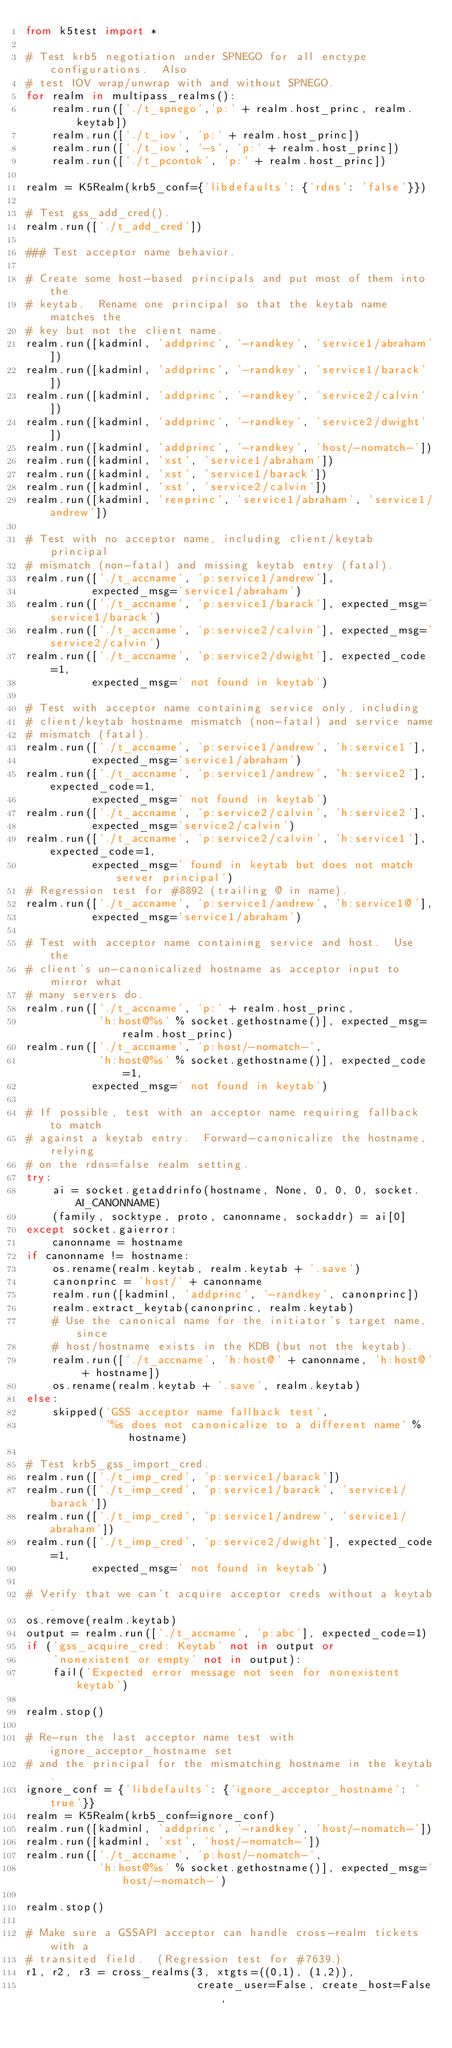Convert code to text. <code><loc_0><loc_0><loc_500><loc_500><_Python_>from k5test import *

# Test krb5 negotiation under SPNEGO for all enctype configurations.  Also
# test IOV wrap/unwrap with and without SPNEGO.
for realm in multipass_realms():
    realm.run(['./t_spnego','p:' + realm.host_princ, realm.keytab])
    realm.run(['./t_iov', 'p:' + realm.host_princ])
    realm.run(['./t_iov', '-s', 'p:' + realm.host_princ])
    realm.run(['./t_pcontok', 'p:' + realm.host_princ])

realm = K5Realm(krb5_conf={'libdefaults': {'rdns': 'false'}})

# Test gss_add_cred().
realm.run(['./t_add_cred'])

### Test acceptor name behavior.

# Create some host-based principals and put most of them into the
# keytab.  Rename one principal so that the keytab name matches the
# key but not the client name.
realm.run([kadminl, 'addprinc', '-randkey', 'service1/abraham'])
realm.run([kadminl, 'addprinc', '-randkey', 'service1/barack'])
realm.run([kadminl, 'addprinc', '-randkey', 'service2/calvin'])
realm.run([kadminl, 'addprinc', '-randkey', 'service2/dwight'])
realm.run([kadminl, 'addprinc', '-randkey', 'host/-nomatch-'])
realm.run([kadminl, 'xst', 'service1/abraham'])
realm.run([kadminl, 'xst', 'service1/barack'])
realm.run([kadminl, 'xst', 'service2/calvin'])
realm.run([kadminl, 'renprinc', 'service1/abraham', 'service1/andrew'])

# Test with no acceptor name, including client/keytab principal
# mismatch (non-fatal) and missing keytab entry (fatal).
realm.run(['./t_accname', 'p:service1/andrew'],
          expected_msg='service1/abraham')
realm.run(['./t_accname', 'p:service1/barack'], expected_msg='service1/barack')
realm.run(['./t_accname', 'p:service2/calvin'], expected_msg='service2/calvin')
realm.run(['./t_accname', 'p:service2/dwight'], expected_code=1,
          expected_msg=' not found in keytab')

# Test with acceptor name containing service only, including
# client/keytab hostname mismatch (non-fatal) and service name
# mismatch (fatal).
realm.run(['./t_accname', 'p:service1/andrew', 'h:service1'],
          expected_msg='service1/abraham')
realm.run(['./t_accname', 'p:service1/andrew', 'h:service2'], expected_code=1,
          expected_msg=' not found in keytab')
realm.run(['./t_accname', 'p:service2/calvin', 'h:service2'],
          expected_msg='service2/calvin')
realm.run(['./t_accname', 'p:service2/calvin', 'h:service1'], expected_code=1,
          expected_msg=' found in keytab but does not match server principal')
# Regression test for #8892 (trailing @ in name).
realm.run(['./t_accname', 'p:service1/andrew', 'h:service1@'],
          expected_msg='service1/abraham')

# Test with acceptor name containing service and host.  Use the
# client's un-canonicalized hostname as acceptor input to mirror what
# many servers do.
realm.run(['./t_accname', 'p:' + realm.host_princ,
           'h:host@%s' % socket.gethostname()], expected_msg=realm.host_princ)
realm.run(['./t_accname', 'p:host/-nomatch-',
           'h:host@%s' % socket.gethostname()], expected_code=1,
          expected_msg=' not found in keytab')

# If possible, test with an acceptor name requiring fallback to match
# against a keytab entry.  Forward-canonicalize the hostname, relying
# on the rdns=false realm setting.
try:
    ai = socket.getaddrinfo(hostname, None, 0, 0, 0, socket.AI_CANONNAME)
    (family, socktype, proto, canonname, sockaddr) = ai[0]
except socket.gaierror:
    canonname = hostname
if canonname != hostname:
    os.rename(realm.keytab, realm.keytab + '.save')
    canonprinc = 'host/' + canonname
    realm.run([kadminl, 'addprinc', '-randkey', canonprinc])
    realm.extract_keytab(canonprinc, realm.keytab)
    # Use the canonical name for the initiator's target name, since
    # host/hostname exists in the KDB (but not the keytab).
    realm.run(['./t_accname', 'h:host@' + canonname, 'h:host@' + hostname])
    os.rename(realm.keytab + '.save', realm.keytab)
else:
    skipped('GSS acceptor name fallback test',
            '%s does not canonicalize to a different name' % hostname)

# Test krb5_gss_import_cred.
realm.run(['./t_imp_cred', 'p:service1/barack'])
realm.run(['./t_imp_cred', 'p:service1/barack', 'service1/barack'])
realm.run(['./t_imp_cred', 'p:service1/andrew', 'service1/abraham'])
realm.run(['./t_imp_cred', 'p:service2/dwight'], expected_code=1,
          expected_msg=' not found in keytab')

# Verify that we can't acquire acceptor creds without a keytab.
os.remove(realm.keytab)
output = realm.run(['./t_accname', 'p:abc'], expected_code=1)
if ('gss_acquire_cred: Keytab' not in output or
    'nonexistent or empty' not in output):
    fail('Expected error message not seen for nonexistent keytab')

realm.stop()

# Re-run the last acceptor name test with ignore_acceptor_hostname set
# and the principal for the mismatching hostname in the keytab.
ignore_conf = {'libdefaults': {'ignore_acceptor_hostname': 'true'}}
realm = K5Realm(krb5_conf=ignore_conf)
realm.run([kadminl, 'addprinc', '-randkey', 'host/-nomatch-'])
realm.run([kadminl, 'xst', 'host/-nomatch-'])
realm.run(['./t_accname', 'p:host/-nomatch-',
           'h:host@%s' % socket.gethostname()], expected_msg='host/-nomatch-')

realm.stop()

# Make sure a GSSAPI acceptor can handle cross-realm tickets with a
# transited field.  (Regression test for #7639.)
r1, r2, r3 = cross_realms(3, xtgts=((0,1), (1,2)),
                          create_user=False, create_host=False,</code> 